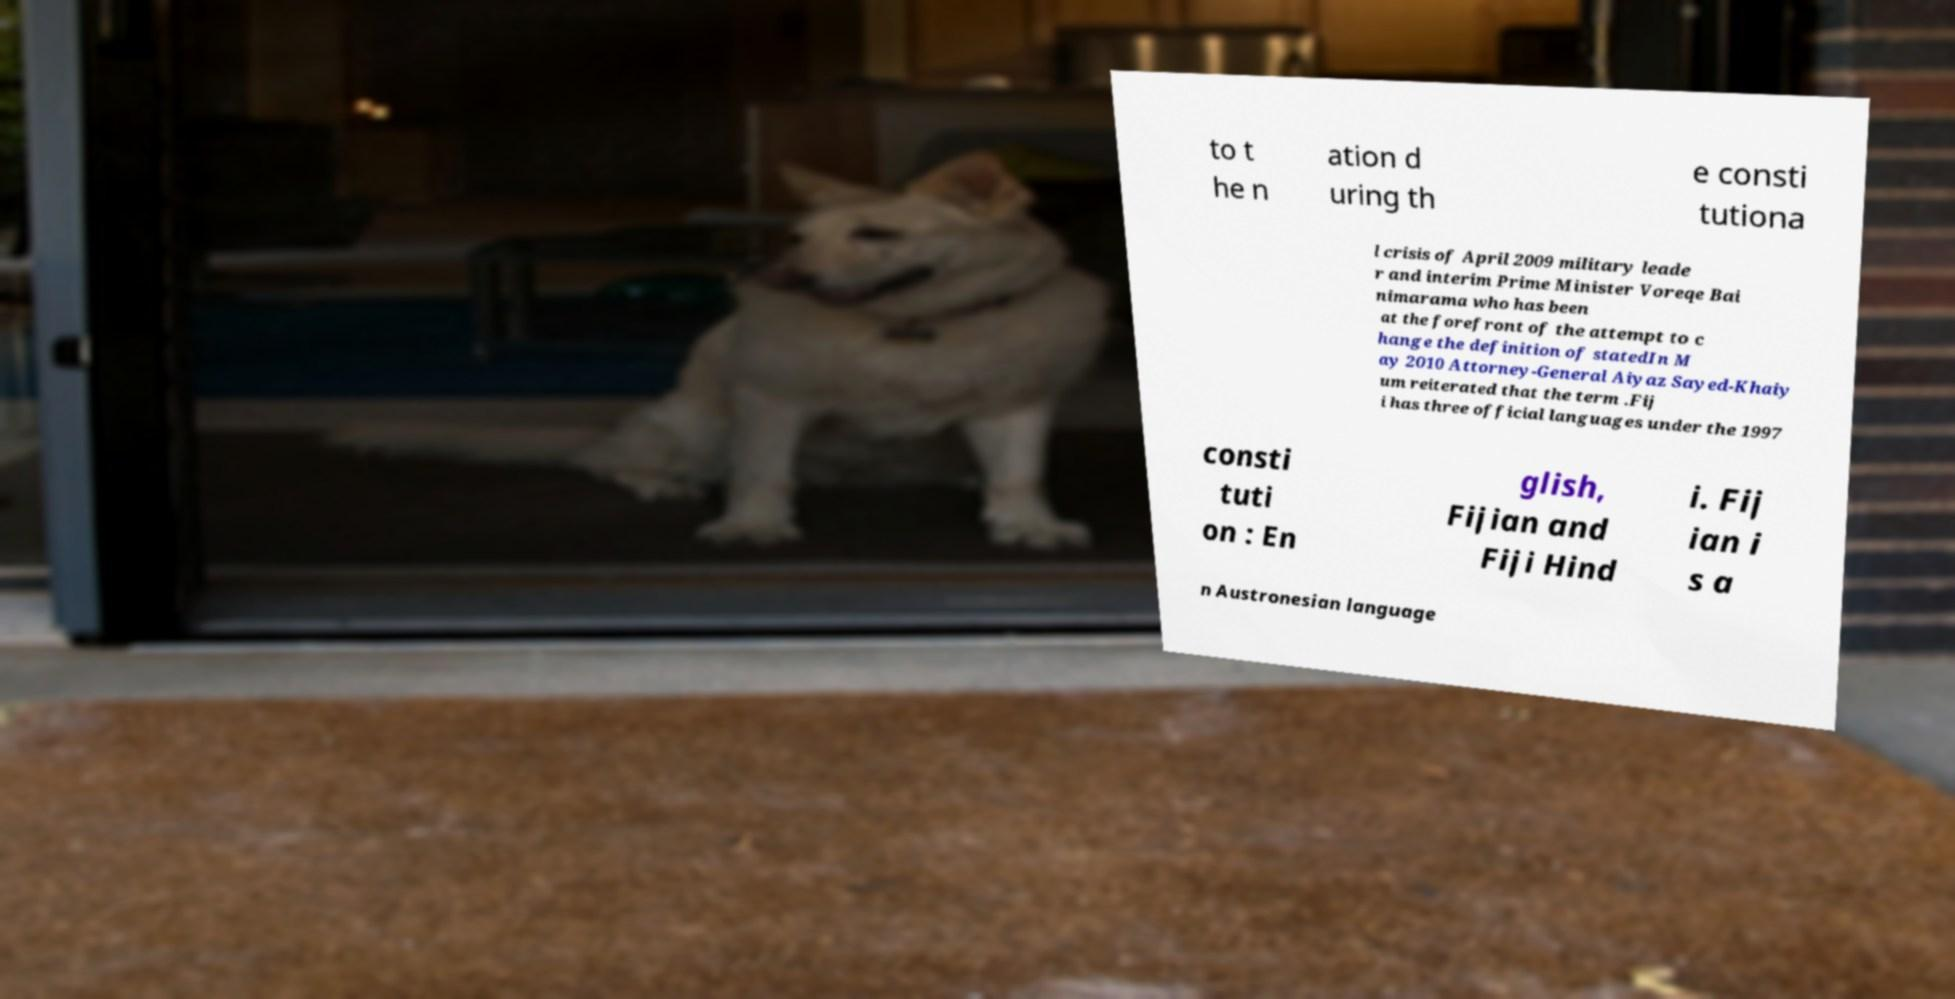There's text embedded in this image that I need extracted. Can you transcribe it verbatim? to t he n ation d uring th e consti tutiona l crisis of April 2009 military leade r and interim Prime Minister Voreqe Bai nimarama who has been at the forefront of the attempt to c hange the definition of statedIn M ay 2010 Attorney-General Aiyaz Sayed-Khaiy um reiterated that the term .Fij i has three official languages under the 1997 consti tuti on : En glish, Fijian and Fiji Hind i. Fij ian i s a n Austronesian language 